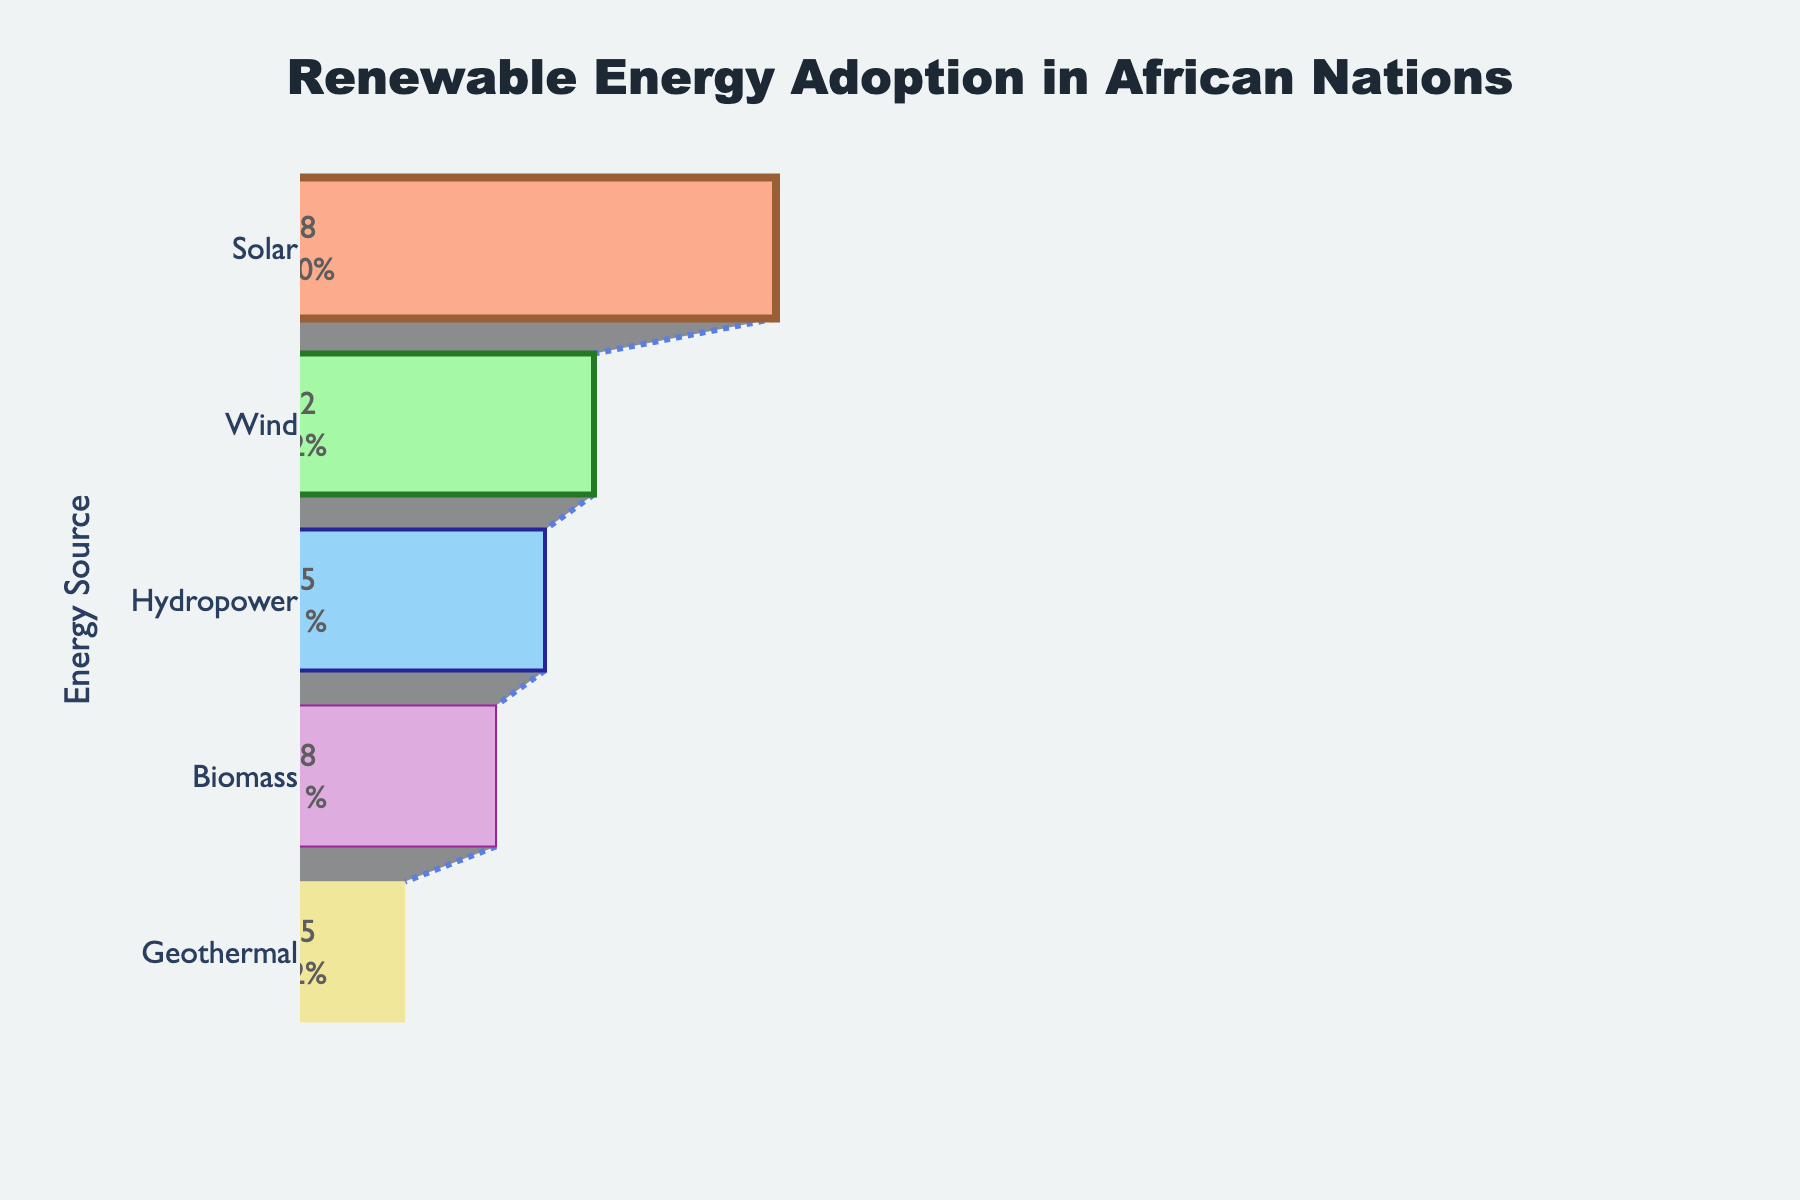which energy source has the highest adoption percentage? The chart shows the adoption percentages of various renewable energy sources. The funnel section with the largest width represents the highest adoption percentage. In this case, it's the solar energy source.
Answer: Solar which energy source has the lowest adoption percentage? Observing the funnel chart, the section with the narrowest width indicates the lowest adoption percentage. This belongs to the geothermal energy source.
Answer: Geothermal what is the total adoption percentage if we sum solar and wind energy? Adding the adoption percentages for solar and wind energy: 68% (solar) + 42% (wind) = 110%.
Answer: 110 how does wind energy adoption compare to biomass energy adoption? The adoption percentage for wind energy is 42%, while for biomass energy, it is 28%. Wind energy has a higher adoption percentage compared to biomass energy.
Answer: Wind energy has a higher adoption percentage than biomass energy by how much does hydropower adoption exceed geothermal adoption? The adoption percentage for hydropower is 35%, and for geothermal, it is 15%. The difference is 35% - 15% = 20%.
Answer: 20 which energy source is positioned third in terms of adoption percentage? The third widest section in the funnel chart represents the third highest adoption percentage, which is hydropower at 35%.
Answer: Hydropower what is the average adoption percentage of all the renewable energy sources shown? Sum the adoption percentages of all energy sources: 68% (solar) + 42% (wind) + 35% (hydropower) + 28% (biomass) + 15% (geothermal) = 188%. Divide by the number of sources (5): 188% / 5 = 37.6%.
Answer: 37.6 what percentage of the total does biomass energy's adoption represent among the given energy sources? The total adoption percentage summing all sources is 188%. Biomass energy's adoption percentage is 28%. The percentage representation is (28 / 188) * 100 ≈ 14.89%.
Answer: 14.89 is the adoption percentage of solar energy more than double the adoption percentage of geothermal energy? The adoption percentage of solar energy is 68%, and geothermal is 15%. Double the geothermal adoption is 15% * 2 = 30%. Since 68% > 30%, solar energy adoption is more than double geothermal's.
Answer: Yes 